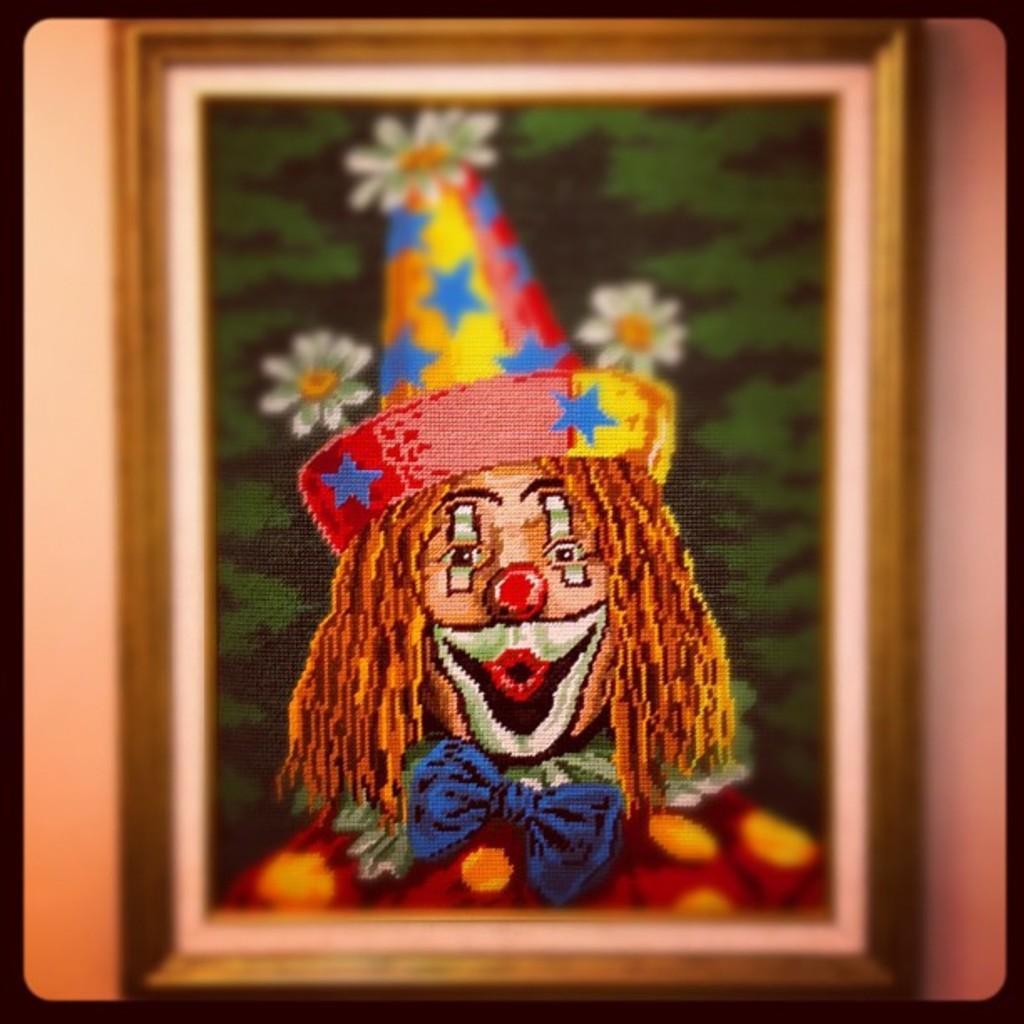How would you summarize this image in a sentence or two? In this picture we can see a photo frame, there is a picture of a person and flowers in the frame, there is a plane background. 